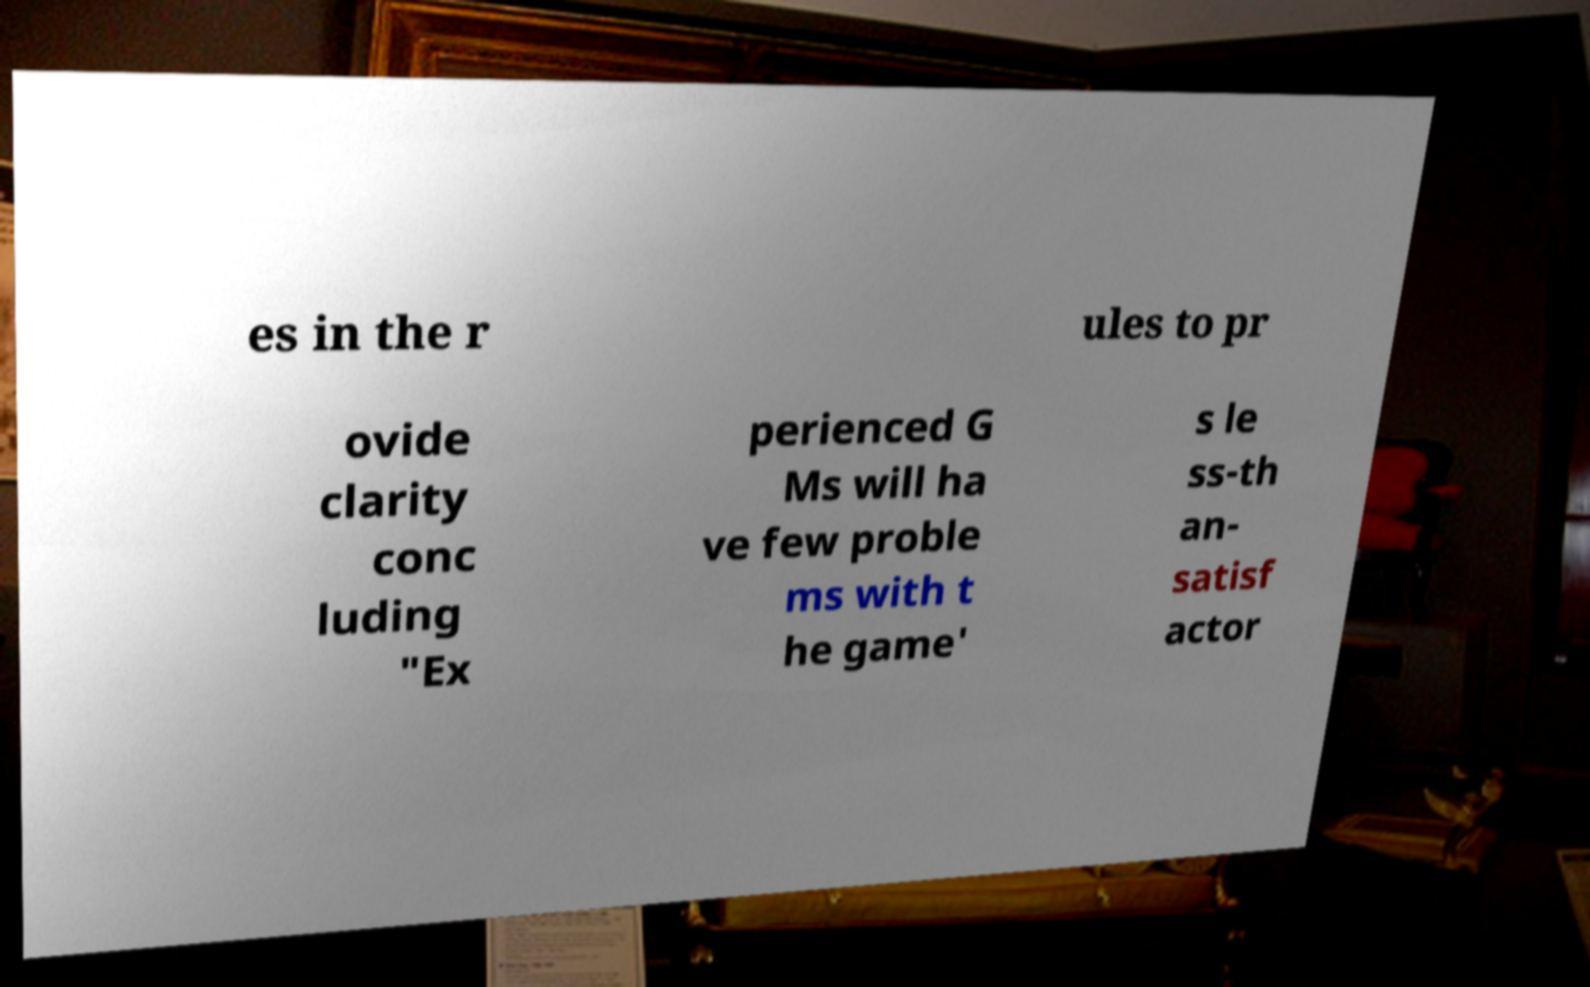Could you extract and type out the text from this image? es in the r ules to pr ovide clarity conc luding "Ex perienced G Ms will ha ve few proble ms with t he game' s le ss-th an- satisf actor 